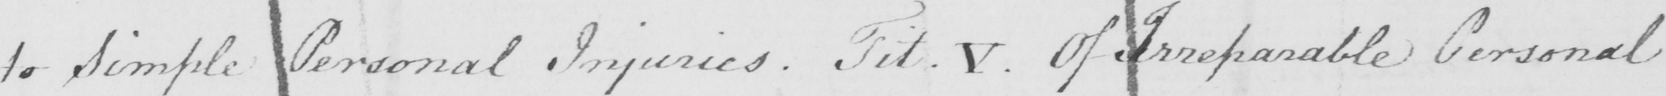What does this handwritten line say? to Simple Personal Injuries . Tit . V . Of Irreparable Personal 